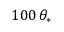Convert formula to latex. <formula><loc_0><loc_0><loc_500><loc_500>1 0 0 \, \theta _ { * }</formula> 